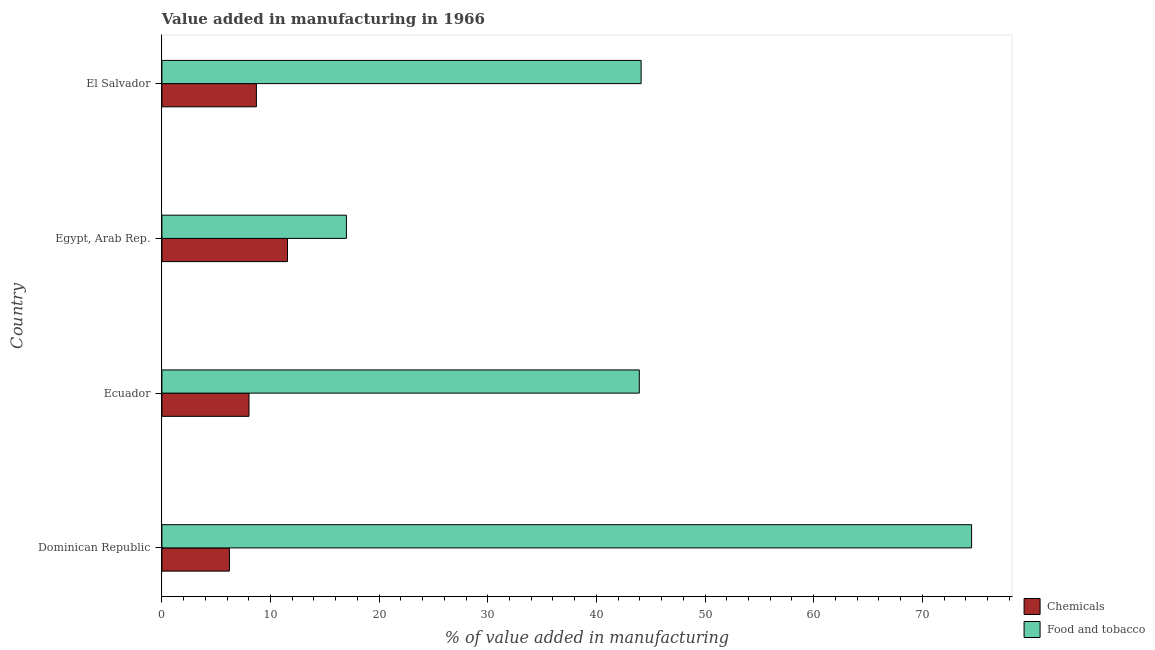How many different coloured bars are there?
Give a very brief answer. 2. Are the number of bars per tick equal to the number of legend labels?
Ensure brevity in your answer.  Yes. How many bars are there on the 1st tick from the bottom?
Keep it short and to the point. 2. What is the label of the 1st group of bars from the top?
Make the answer very short. El Salvador. What is the value added by manufacturing food and tobacco in Dominican Republic?
Your answer should be compact. 74.53. Across all countries, what is the maximum value added by  manufacturing chemicals?
Offer a terse response. 11.56. Across all countries, what is the minimum value added by manufacturing food and tobacco?
Keep it short and to the point. 16.98. In which country was the value added by  manufacturing chemicals maximum?
Give a very brief answer. Egypt, Arab Rep. In which country was the value added by  manufacturing chemicals minimum?
Your response must be concise. Dominican Republic. What is the total value added by  manufacturing chemicals in the graph?
Provide a succinct answer. 34.49. What is the difference between the value added by manufacturing food and tobacco in Dominican Republic and that in Ecuador?
Make the answer very short. 30.59. What is the difference between the value added by manufacturing food and tobacco in Dominican Republic and the value added by  manufacturing chemicals in El Salvador?
Your answer should be very brief. 65.84. What is the average value added by  manufacturing chemicals per country?
Give a very brief answer. 8.62. What is the difference between the value added by manufacturing food and tobacco and value added by  manufacturing chemicals in Dominican Republic?
Give a very brief answer. 68.32. What is the ratio of the value added by manufacturing food and tobacco in Dominican Republic to that in Ecuador?
Give a very brief answer. 1.7. Is the value added by manufacturing food and tobacco in Egypt, Arab Rep. less than that in El Salvador?
Make the answer very short. Yes. What is the difference between the highest and the second highest value added by manufacturing food and tobacco?
Ensure brevity in your answer.  30.42. What is the difference between the highest and the lowest value added by  manufacturing chemicals?
Provide a short and direct response. 5.35. In how many countries, is the value added by manufacturing food and tobacco greater than the average value added by manufacturing food and tobacco taken over all countries?
Provide a succinct answer. 1. Is the sum of the value added by  manufacturing chemicals in Egypt, Arab Rep. and El Salvador greater than the maximum value added by manufacturing food and tobacco across all countries?
Ensure brevity in your answer.  No. What does the 2nd bar from the top in Ecuador represents?
Provide a short and direct response. Chemicals. What does the 2nd bar from the bottom in Egypt, Arab Rep. represents?
Provide a short and direct response. Food and tobacco. How many bars are there?
Provide a short and direct response. 8. Are all the bars in the graph horizontal?
Provide a short and direct response. Yes. How many countries are there in the graph?
Your response must be concise. 4. What is the difference between two consecutive major ticks on the X-axis?
Give a very brief answer. 10. Are the values on the major ticks of X-axis written in scientific E-notation?
Give a very brief answer. No. Does the graph contain grids?
Make the answer very short. No. What is the title of the graph?
Your answer should be compact. Value added in manufacturing in 1966. What is the label or title of the X-axis?
Provide a succinct answer. % of value added in manufacturing. What is the % of value added in manufacturing of Chemicals in Dominican Republic?
Your answer should be very brief. 6.21. What is the % of value added in manufacturing in Food and tobacco in Dominican Republic?
Provide a succinct answer. 74.53. What is the % of value added in manufacturing of Chemicals in Ecuador?
Give a very brief answer. 8.02. What is the % of value added in manufacturing of Food and tobacco in Ecuador?
Offer a very short reply. 43.95. What is the % of value added in manufacturing of Chemicals in Egypt, Arab Rep.?
Make the answer very short. 11.56. What is the % of value added in manufacturing in Food and tobacco in Egypt, Arab Rep.?
Your answer should be compact. 16.98. What is the % of value added in manufacturing of Chemicals in El Salvador?
Keep it short and to the point. 8.7. What is the % of value added in manufacturing of Food and tobacco in El Salvador?
Provide a short and direct response. 44.11. Across all countries, what is the maximum % of value added in manufacturing in Chemicals?
Provide a succinct answer. 11.56. Across all countries, what is the maximum % of value added in manufacturing of Food and tobacco?
Offer a terse response. 74.53. Across all countries, what is the minimum % of value added in manufacturing in Chemicals?
Your answer should be compact. 6.21. Across all countries, what is the minimum % of value added in manufacturing of Food and tobacco?
Your answer should be very brief. 16.98. What is the total % of value added in manufacturing of Chemicals in the graph?
Make the answer very short. 34.49. What is the total % of value added in manufacturing of Food and tobacco in the graph?
Offer a very short reply. 179.58. What is the difference between the % of value added in manufacturing of Chemicals in Dominican Republic and that in Ecuador?
Provide a short and direct response. -1.8. What is the difference between the % of value added in manufacturing of Food and tobacco in Dominican Republic and that in Ecuador?
Offer a terse response. 30.59. What is the difference between the % of value added in manufacturing in Chemicals in Dominican Republic and that in Egypt, Arab Rep.?
Offer a very short reply. -5.35. What is the difference between the % of value added in manufacturing of Food and tobacco in Dominican Republic and that in Egypt, Arab Rep.?
Provide a succinct answer. 57.55. What is the difference between the % of value added in manufacturing in Chemicals in Dominican Republic and that in El Salvador?
Offer a terse response. -2.48. What is the difference between the % of value added in manufacturing of Food and tobacco in Dominican Republic and that in El Salvador?
Offer a very short reply. 30.42. What is the difference between the % of value added in manufacturing of Chemicals in Ecuador and that in Egypt, Arab Rep.?
Provide a short and direct response. -3.54. What is the difference between the % of value added in manufacturing of Food and tobacco in Ecuador and that in Egypt, Arab Rep.?
Your answer should be very brief. 26.96. What is the difference between the % of value added in manufacturing in Chemicals in Ecuador and that in El Salvador?
Your response must be concise. -0.68. What is the difference between the % of value added in manufacturing of Food and tobacco in Ecuador and that in El Salvador?
Your answer should be compact. -0.17. What is the difference between the % of value added in manufacturing in Chemicals in Egypt, Arab Rep. and that in El Salvador?
Offer a very short reply. 2.86. What is the difference between the % of value added in manufacturing of Food and tobacco in Egypt, Arab Rep. and that in El Salvador?
Offer a terse response. -27.13. What is the difference between the % of value added in manufacturing of Chemicals in Dominican Republic and the % of value added in manufacturing of Food and tobacco in Ecuador?
Provide a short and direct response. -37.73. What is the difference between the % of value added in manufacturing in Chemicals in Dominican Republic and the % of value added in manufacturing in Food and tobacco in Egypt, Arab Rep.?
Offer a terse response. -10.77. What is the difference between the % of value added in manufacturing of Chemicals in Dominican Republic and the % of value added in manufacturing of Food and tobacco in El Salvador?
Your answer should be very brief. -37.9. What is the difference between the % of value added in manufacturing of Chemicals in Ecuador and the % of value added in manufacturing of Food and tobacco in Egypt, Arab Rep.?
Offer a very short reply. -8.97. What is the difference between the % of value added in manufacturing in Chemicals in Ecuador and the % of value added in manufacturing in Food and tobacco in El Salvador?
Offer a terse response. -36.1. What is the difference between the % of value added in manufacturing in Chemicals in Egypt, Arab Rep. and the % of value added in manufacturing in Food and tobacco in El Salvador?
Your response must be concise. -32.55. What is the average % of value added in manufacturing of Chemicals per country?
Your answer should be very brief. 8.62. What is the average % of value added in manufacturing of Food and tobacco per country?
Ensure brevity in your answer.  44.89. What is the difference between the % of value added in manufacturing of Chemicals and % of value added in manufacturing of Food and tobacco in Dominican Republic?
Give a very brief answer. -68.32. What is the difference between the % of value added in manufacturing in Chemicals and % of value added in manufacturing in Food and tobacco in Ecuador?
Offer a terse response. -35.93. What is the difference between the % of value added in manufacturing in Chemicals and % of value added in manufacturing in Food and tobacco in Egypt, Arab Rep.?
Provide a succinct answer. -5.42. What is the difference between the % of value added in manufacturing in Chemicals and % of value added in manufacturing in Food and tobacco in El Salvador?
Your answer should be very brief. -35.42. What is the ratio of the % of value added in manufacturing of Chemicals in Dominican Republic to that in Ecuador?
Provide a short and direct response. 0.78. What is the ratio of the % of value added in manufacturing in Food and tobacco in Dominican Republic to that in Ecuador?
Give a very brief answer. 1.7. What is the ratio of the % of value added in manufacturing of Chemicals in Dominican Republic to that in Egypt, Arab Rep.?
Provide a succinct answer. 0.54. What is the ratio of the % of value added in manufacturing in Food and tobacco in Dominican Republic to that in Egypt, Arab Rep.?
Make the answer very short. 4.39. What is the ratio of the % of value added in manufacturing of Chemicals in Dominican Republic to that in El Salvador?
Offer a terse response. 0.71. What is the ratio of the % of value added in manufacturing in Food and tobacco in Dominican Republic to that in El Salvador?
Ensure brevity in your answer.  1.69. What is the ratio of the % of value added in manufacturing in Chemicals in Ecuador to that in Egypt, Arab Rep.?
Offer a very short reply. 0.69. What is the ratio of the % of value added in manufacturing of Food and tobacco in Ecuador to that in Egypt, Arab Rep.?
Your answer should be very brief. 2.59. What is the ratio of the % of value added in manufacturing of Chemicals in Ecuador to that in El Salvador?
Provide a succinct answer. 0.92. What is the ratio of the % of value added in manufacturing in Food and tobacco in Ecuador to that in El Salvador?
Your response must be concise. 1. What is the ratio of the % of value added in manufacturing of Chemicals in Egypt, Arab Rep. to that in El Salvador?
Provide a succinct answer. 1.33. What is the ratio of the % of value added in manufacturing in Food and tobacco in Egypt, Arab Rep. to that in El Salvador?
Your answer should be very brief. 0.39. What is the difference between the highest and the second highest % of value added in manufacturing of Chemicals?
Ensure brevity in your answer.  2.86. What is the difference between the highest and the second highest % of value added in manufacturing in Food and tobacco?
Keep it short and to the point. 30.42. What is the difference between the highest and the lowest % of value added in manufacturing of Chemicals?
Your response must be concise. 5.35. What is the difference between the highest and the lowest % of value added in manufacturing of Food and tobacco?
Keep it short and to the point. 57.55. 